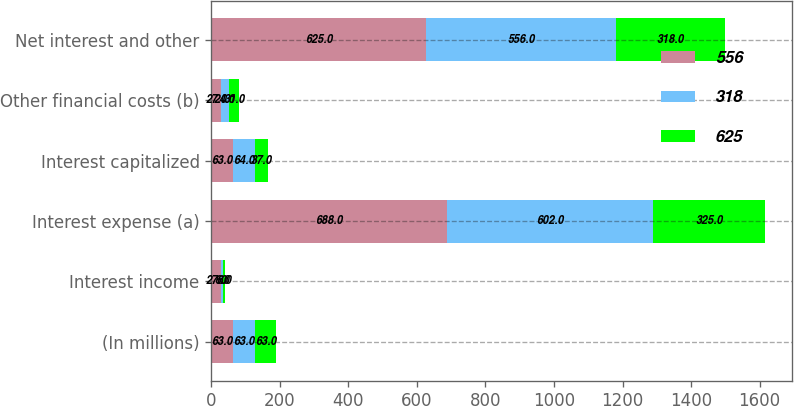Convert chart. <chart><loc_0><loc_0><loc_500><loc_500><stacked_bar_chart><ecel><fcel>(In millions)<fcel>Interest income<fcel>Interest expense (a)<fcel>Interest capitalized<fcel>Other financial costs (b)<fcel>Net interest and other<nl><fcel>556<fcel>63<fcel>27<fcel>688<fcel>63<fcel>27<fcel>625<nl><fcel>318<fcel>63<fcel>6<fcel>602<fcel>64<fcel>24<fcel>556<nl><fcel>625<fcel>63<fcel>6<fcel>325<fcel>37<fcel>31<fcel>318<nl></chart> 